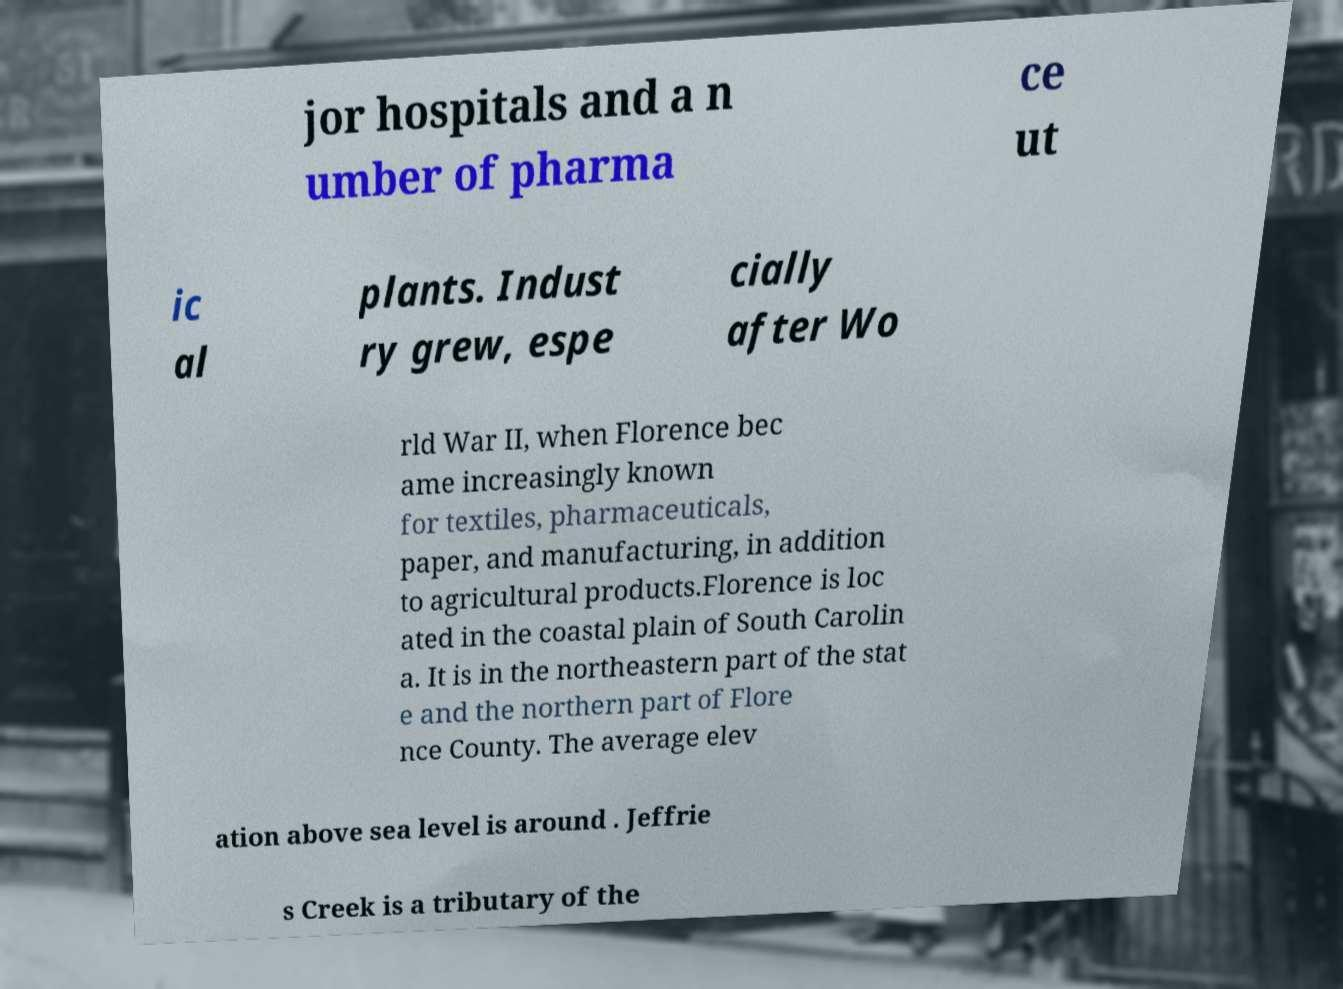For documentation purposes, I need the text within this image transcribed. Could you provide that? jor hospitals and a n umber of pharma ce ut ic al plants. Indust ry grew, espe cially after Wo rld War II, when Florence bec ame increasingly known for textiles, pharmaceuticals, paper, and manufacturing, in addition to agricultural products.Florence is loc ated in the coastal plain of South Carolin a. It is in the northeastern part of the stat e and the northern part of Flore nce County. The average elev ation above sea level is around . Jeffrie s Creek is a tributary of the 